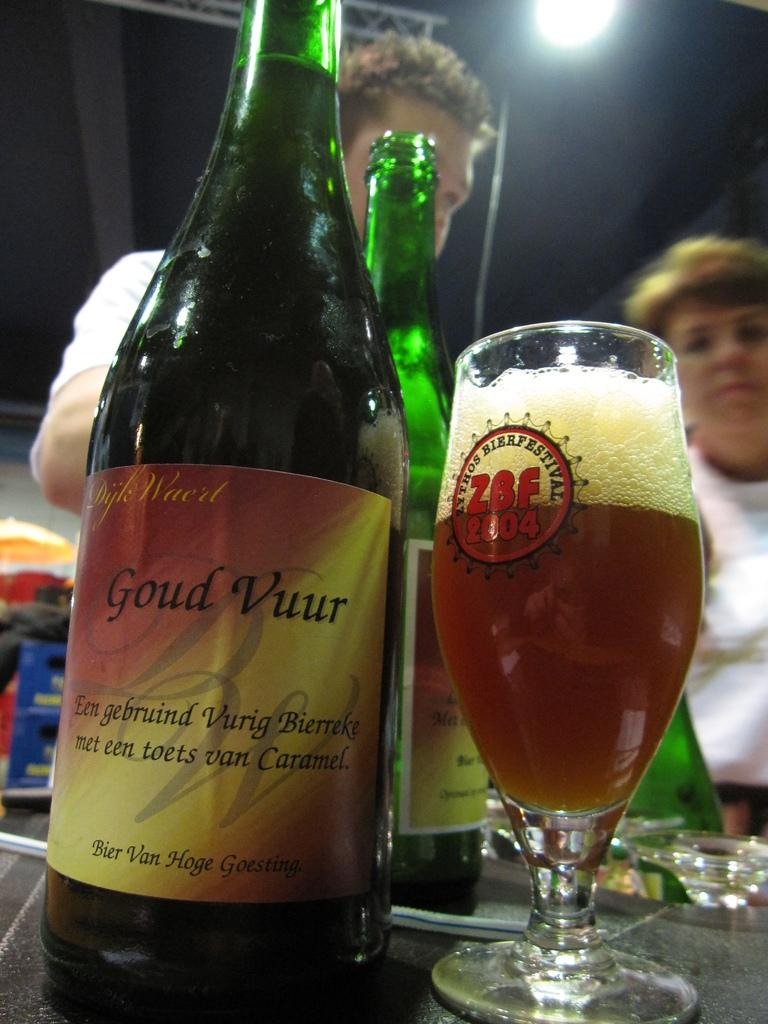<image>
Create a compact narrative representing the image presented. A beer glass sports a ZBF 2004 design representing a specific beer festival. 